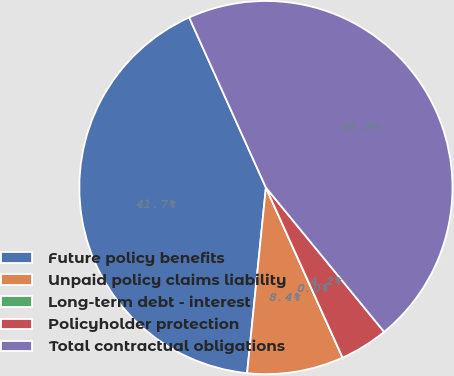<chart> <loc_0><loc_0><loc_500><loc_500><pie_chart><fcel>Future policy benefits<fcel>Unpaid policy claims liability<fcel>Long-term debt - interest<fcel>Policyholder protection<fcel>Total contractual obligations<nl><fcel>41.65%<fcel>8.35%<fcel>0.0%<fcel>4.18%<fcel>45.82%<nl></chart> 